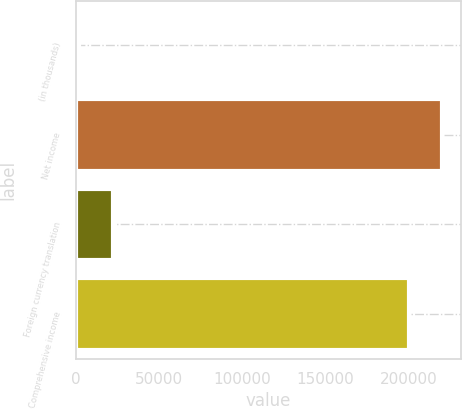<chart> <loc_0><loc_0><loc_500><loc_500><bar_chart><fcel>(in thousands)<fcel>Net income<fcel>Foreign currency translation<fcel>Comprehensive income<nl><fcel>2012<fcel>220405<fcel>22159.1<fcel>200258<nl></chart> 